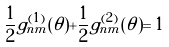<formula> <loc_0><loc_0><loc_500><loc_500>\frac { 1 } { 2 } g _ { n m } ^ { ( 1 ) } ( \theta ) + \frac { 1 } { 2 } g _ { n m } ^ { ( 2 ) } ( \theta ) = 1</formula> 